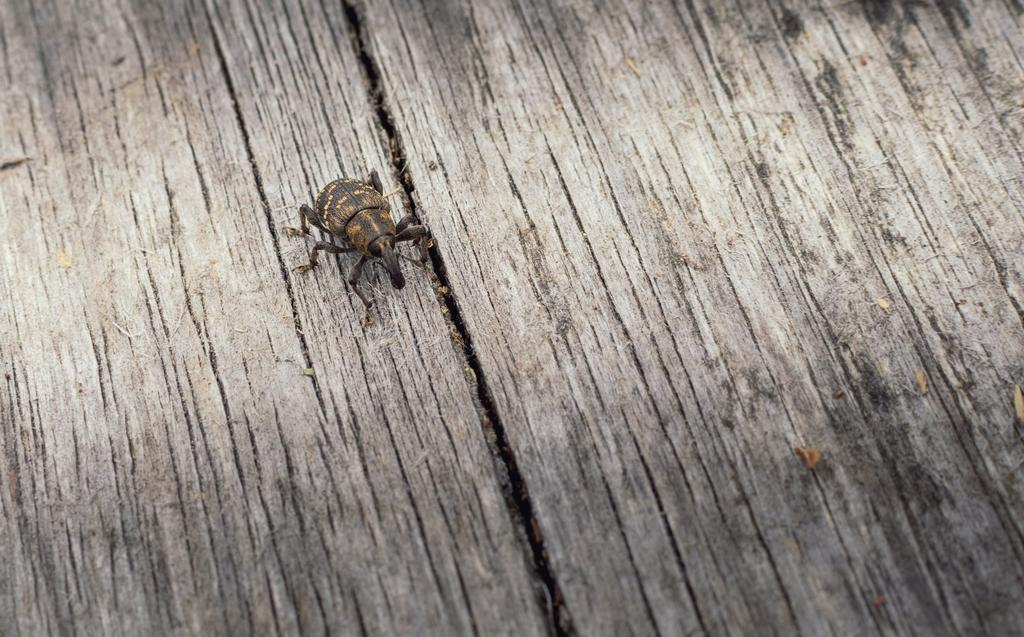What is present on the wooden surface in the image? There is an insect in the image. What is the color of the insect? The insect is brown in color. How does the insect show respect to the match on the wooden surface? There is no match present in the image, and insects do not have the ability to show respect. 